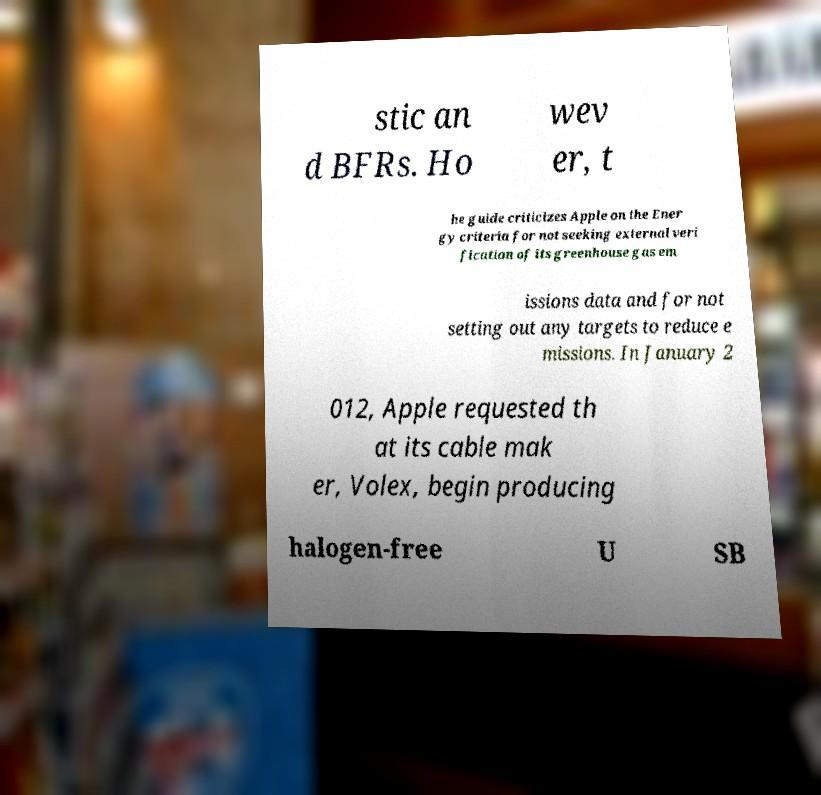Can you read and provide the text displayed in the image?This photo seems to have some interesting text. Can you extract and type it out for me? stic an d BFRs. Ho wev er, t he guide criticizes Apple on the Ener gy criteria for not seeking external veri fication of its greenhouse gas em issions data and for not setting out any targets to reduce e missions. In January 2 012, Apple requested th at its cable mak er, Volex, begin producing halogen-free U SB 